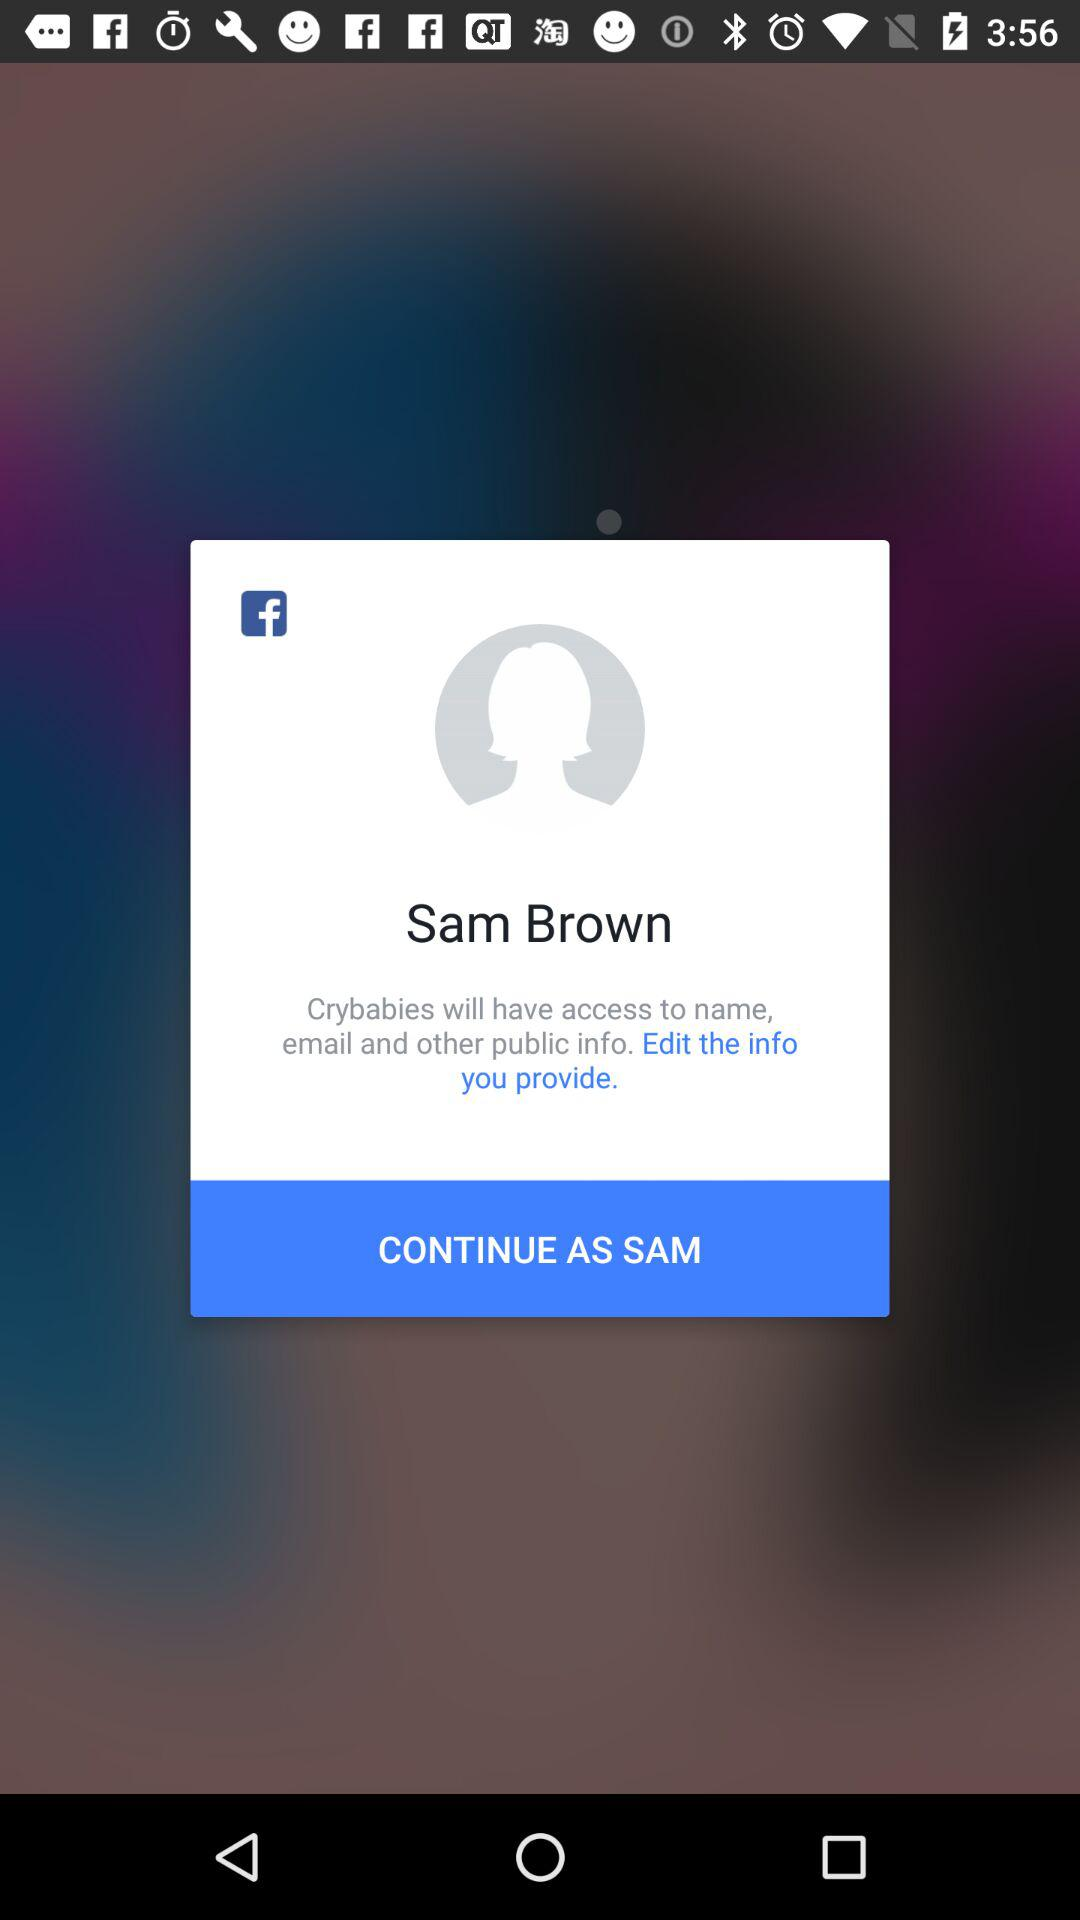What is the user name? The user name is "Sam Brown". 